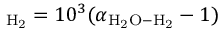<formula> <loc_0><loc_0><loc_500><loc_500>_ { H } _ { 2 } = 1 0 ^ { 3 } ( \alpha _ { H _ { 2 } O - H _ { 2 } } - 1 )</formula> 